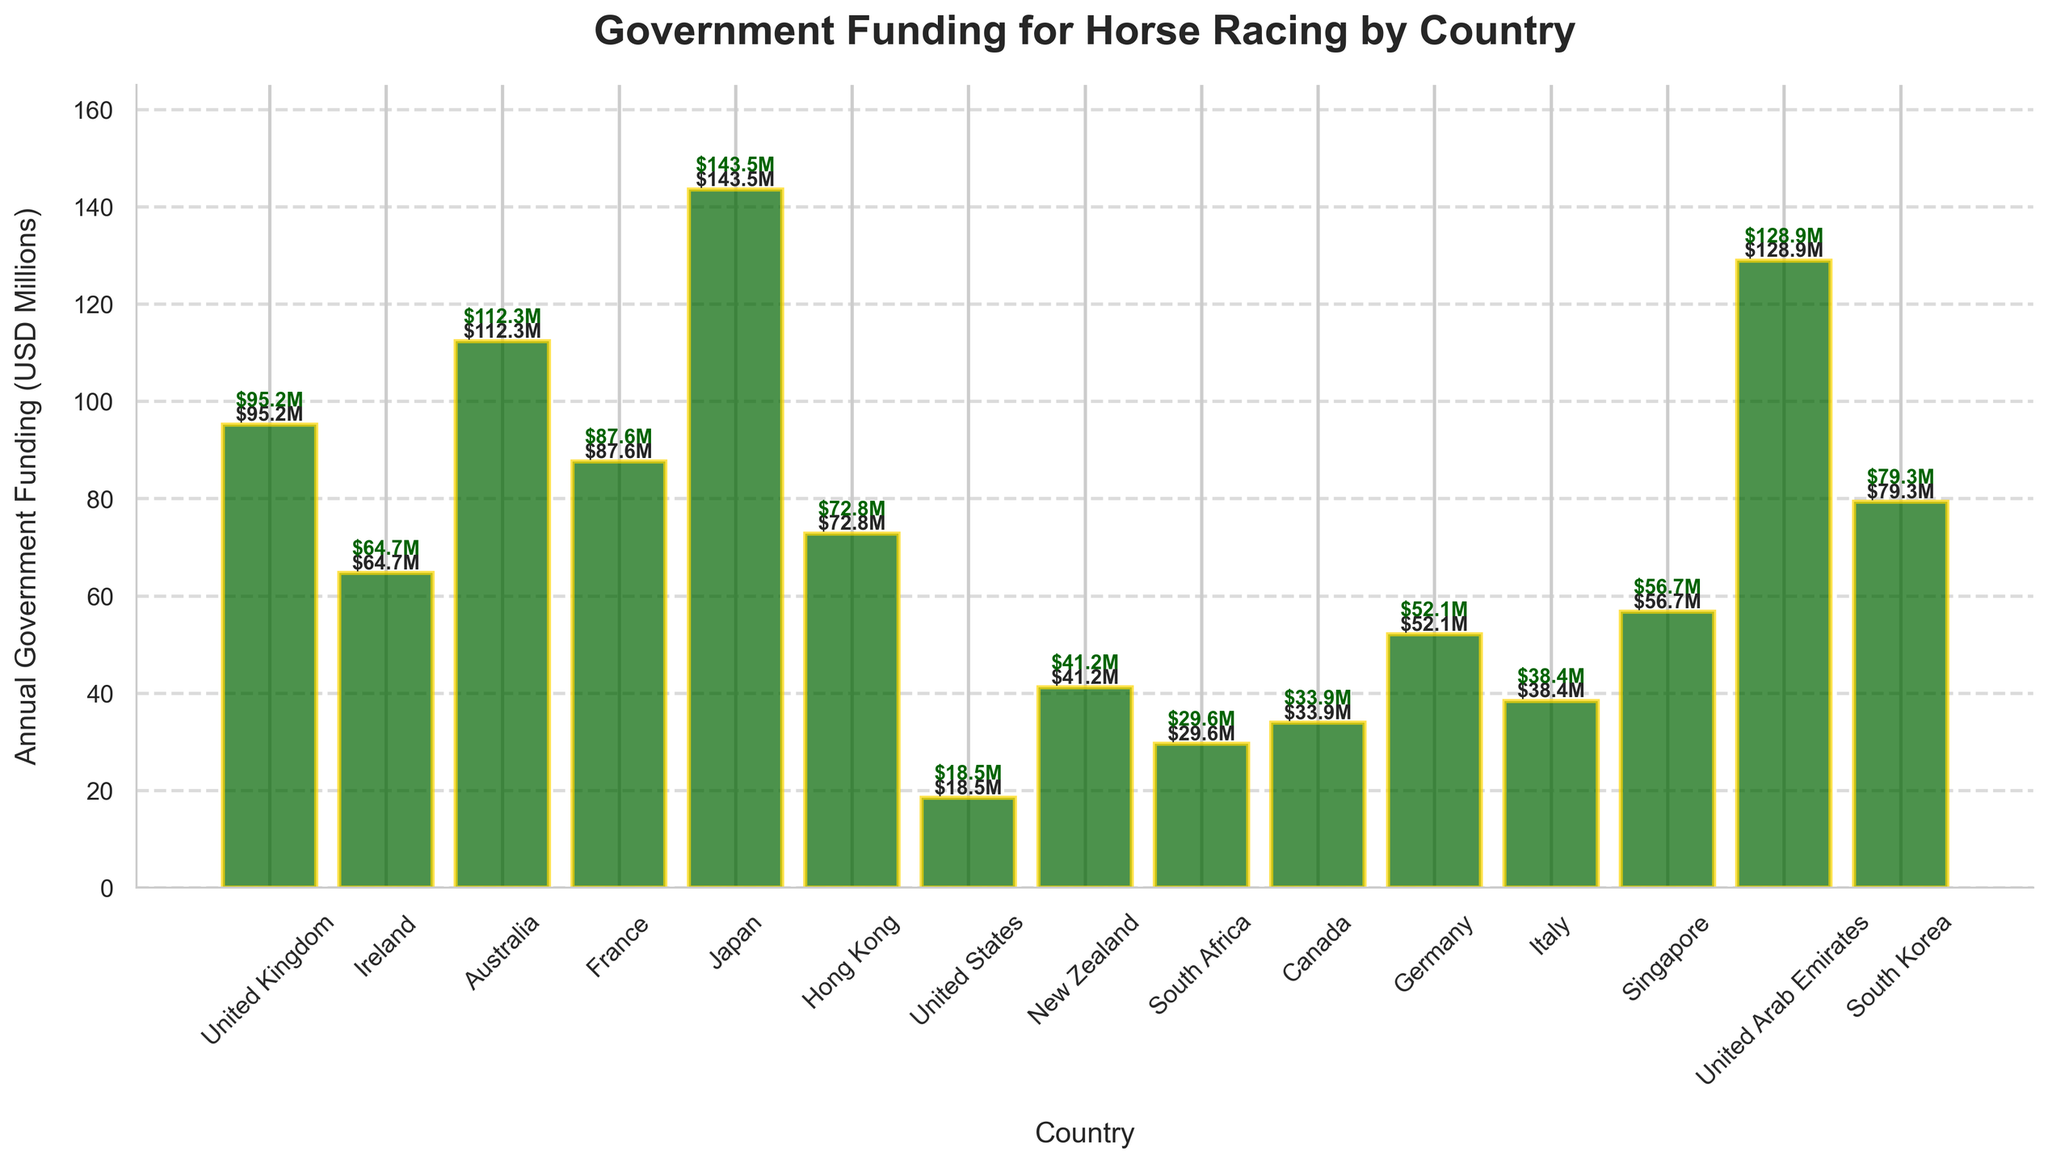Which country receives the highest annual government funding? The bar chart shows the height of each bar, and the tallest bar corresponds to Japan. Thus, Japan receives the highest annual government funding.
Answer: Japan Which country receives the lowest annual government funding? The shortest bar in the bar chart represents the United States, indicating it receives the lowest annual government funding.
Answer: United States What is the difference in government funding between Japan and the United States? From the chart, Japan receives $143.5M and the United States receives $18.5M. The difference is $143.5M - $18.5M = $125M.
Answer: $125M Which country has funding closest to $70 million? The bar representing Hong Kong is closest to $70 million as it indicates $72.8M.
Answer: Hong Kong How does the funding in Australia compare to that in the United Kingdom? The bar for Australia is taller than the one for the United Kingdom. Australia receives $112.3M, while the United Kingdom receives $95.2M.
Answer: Australia > United Kingdom What is the average government funding among the listed countries? Sum all the funding values ($95.2M + $64.7M + $112.3M + $87.6M + $143.5M + $72.8M + $18.5M + $41.2M + $29.6M + $33.9M + $52.1M + $38.4M + $56.7M + $128.9M + $79.3M) = $1,074.7M. Divide by the number of countries (15). Average = $1,074.7M / 15 ≈ $71.65M.
Answer: $71.65M What proportion of the total funding is received by Japan? Japan receives $143.5M. Total funding is $1,074.7M. Proportion = $143.5M / $1,074.7M * 100 ≈ 13.35%.
Answer: 13.35% Which countries receive more than $100 million in funding? By examining the height of the bars, Australia ($112.3M), Japan ($143.5M), and the United Arab Emirates ($128.9M) all receive more than $100 million in funding.
Answer: Australia, Japan, United Arab Emirates What is the median value of government funding for these countries? List the funding values in ascending order: $18.5M, $29.6M, $33.9M, $38.4M, $41.2M, $52.1M, $56.7M, $64.7M, $72.8M, $79.3M, $87.6M, $95.2M, $112.3M, $128.9M, $143.5M. The median value is the one in the middle (8th value), which is $64.7M.
Answer: $64.7M 